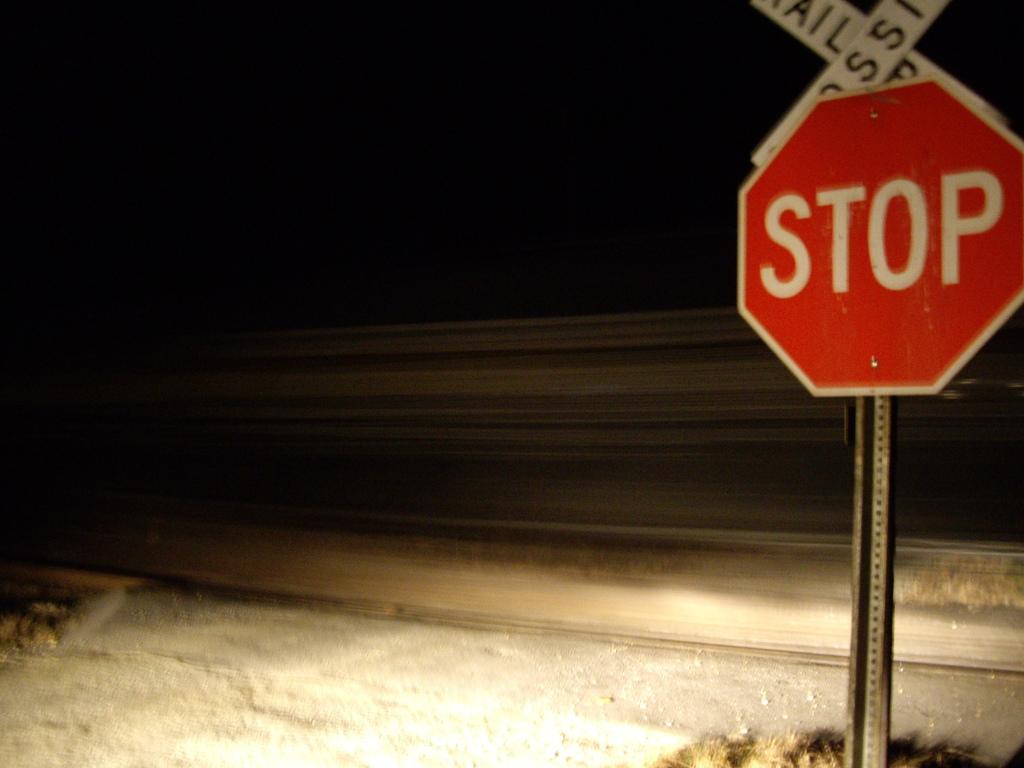What should you do at this sign?
Your response must be concise. Stop. What is this stop sign placed in front of?
Ensure brevity in your answer.  Railroad crossing. 